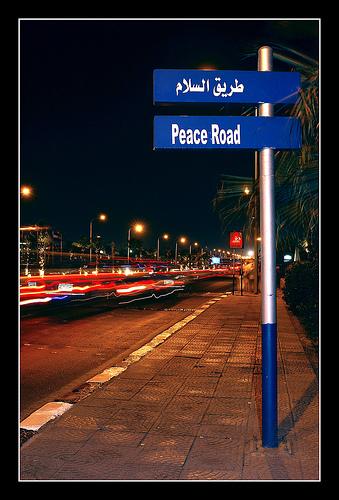What is the bottom color of the pole?
Quick response, please. Blue. Does this environment appear noisy?
Quick response, please. Yes. How many languages are used in the signs?
Write a very short answer. 2. 